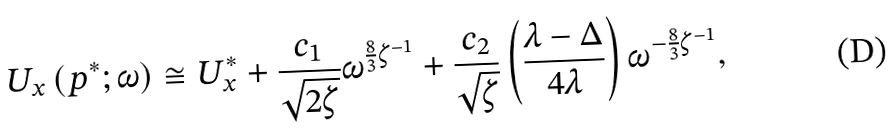Convert formula to latex. <formula><loc_0><loc_0><loc_500><loc_500>U _ { x } \left ( p ^ { * } ; \omega \right ) \cong U _ { x } ^ { * } + \frac { c _ { 1 } } { \sqrt { 2 \zeta } } \omega ^ { \frac { 8 } { 3 } \zeta ^ { - 1 } } + \frac { c _ { 2 } } { \sqrt { \zeta } } \left ( \frac { \lambda - \Delta } { 4 \lambda } \right ) \omega ^ { - \frac { 8 } { 3 } \zeta ^ { - 1 } } ,</formula> 